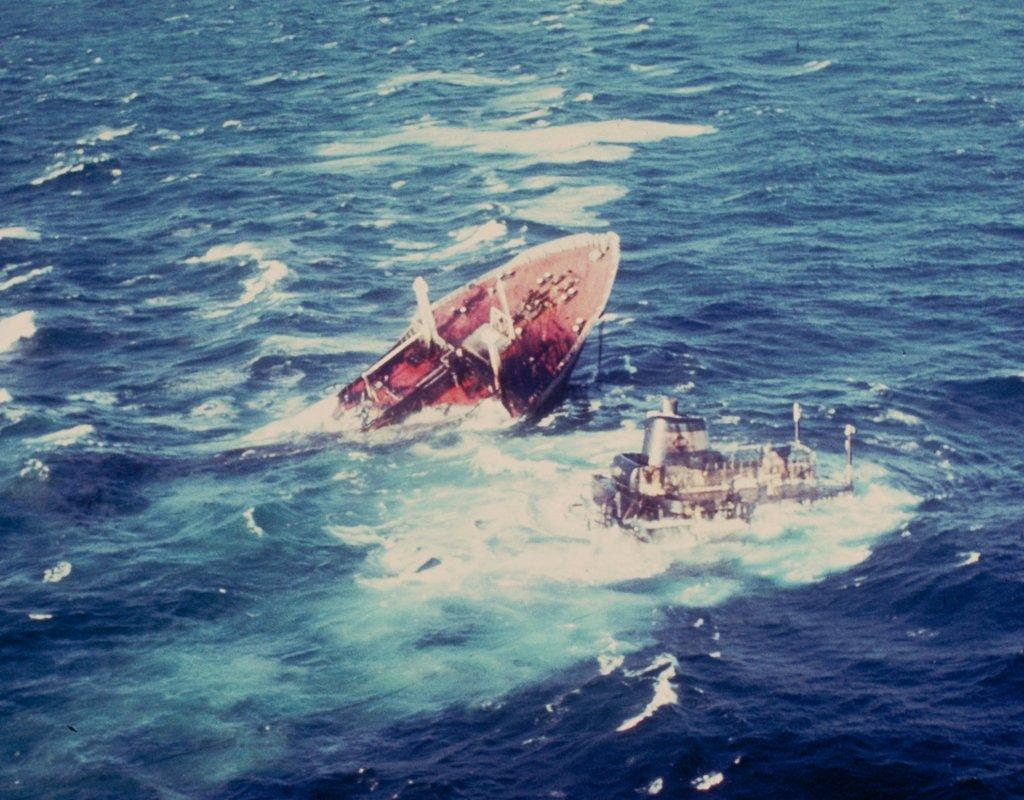What is the main subject of the image? The main subject of the image is two ships. Where are the ships located in the image? The ships are in the center of the image. What is the ships' relationship to the water in the image? The ships appear to be entering the water. What type of environment is depicted in the image? The image shows a water-based environment. How many trucks are visible in the image? There are no trucks present in the image; it features two ships entering the water. What type of birds can be seen flying over the ships in the image? There are no birds visible in the image; it only shows two ships entering the water. 